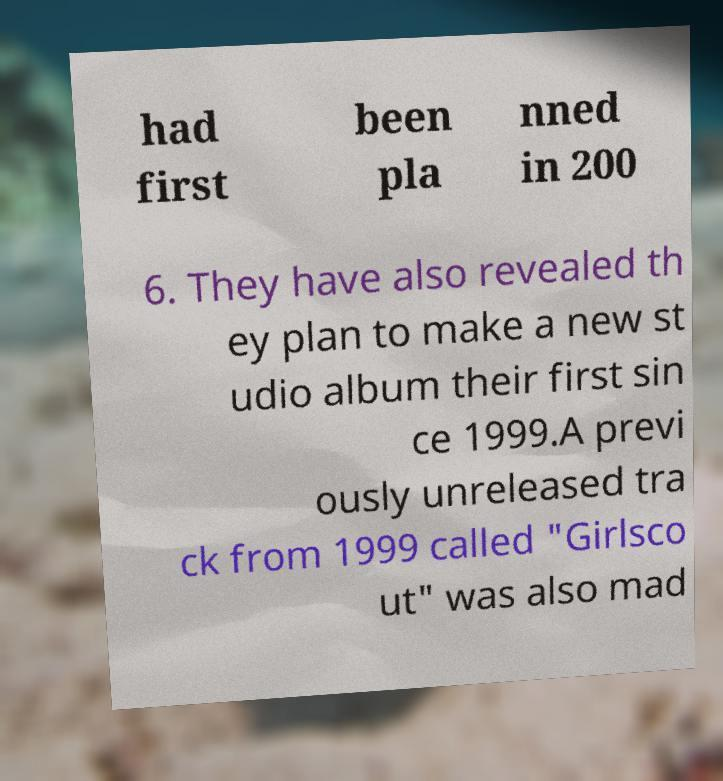There's text embedded in this image that I need extracted. Can you transcribe it verbatim? had first been pla nned in 200 6. They have also revealed th ey plan to make a new st udio album their first sin ce 1999.A previ ously unreleased tra ck from 1999 called "Girlsco ut" was also mad 